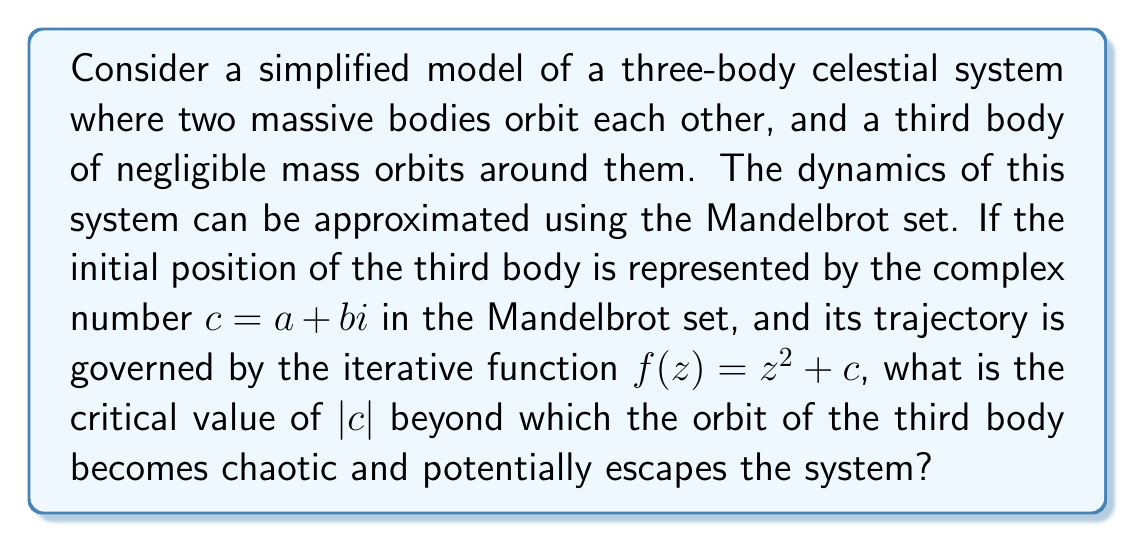Could you help me with this problem? To solve this problem, we need to understand the connection between the Mandelbrot set and the stability of orbits in our simplified celestial system:

1) The Mandelbrot set is defined as the set of complex numbers $c$ for which the function $f(z) = z^2 + c$ does not diverge when iterated from $z = 0$.

2) In our celestial context, $c$ represents the initial position of the third body, and the iterations of $f(z)$ represent its subsequent positions over time.

3) The boundary of the Mandelbrot set corresponds to the transition between stable and chaotic orbits.

4) A key property of the Mandelbrot set is that it is contained within a circle of radius 2 centered at the origin in the complex plane.

5) Mathematically, this means that if $|c| > 2$, the orbit will always escape to infinity (become chaotic).

6) The proof for this comes from the inequality:
   $$|z_{n+1}| = |z_n^2 + c| \geq |z_n|^2 - |c|$$

7) If $|z_n| > 2$ and $|c| \leq 2$, then:
   $$|z_{n+1}| > |z_n|^2 - 2 > 4 - 2 = 2$$

8) This means that once $|z_n|$ exceeds 2, it will continue to grow without bound.

9) Therefore, the critical value of $|c|$ is 2.
Answer: 2 